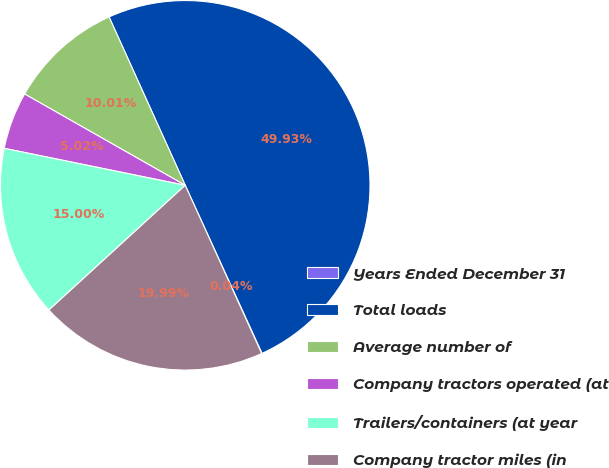Convert chart to OTSL. <chart><loc_0><loc_0><loc_500><loc_500><pie_chart><fcel>Years Ended December 31<fcel>Total loads<fcel>Average number of<fcel>Company tractors operated (at<fcel>Trailers/containers (at year<fcel>Company tractor miles (in<nl><fcel>0.04%<fcel>49.93%<fcel>10.01%<fcel>5.02%<fcel>15.0%<fcel>19.99%<nl></chart> 